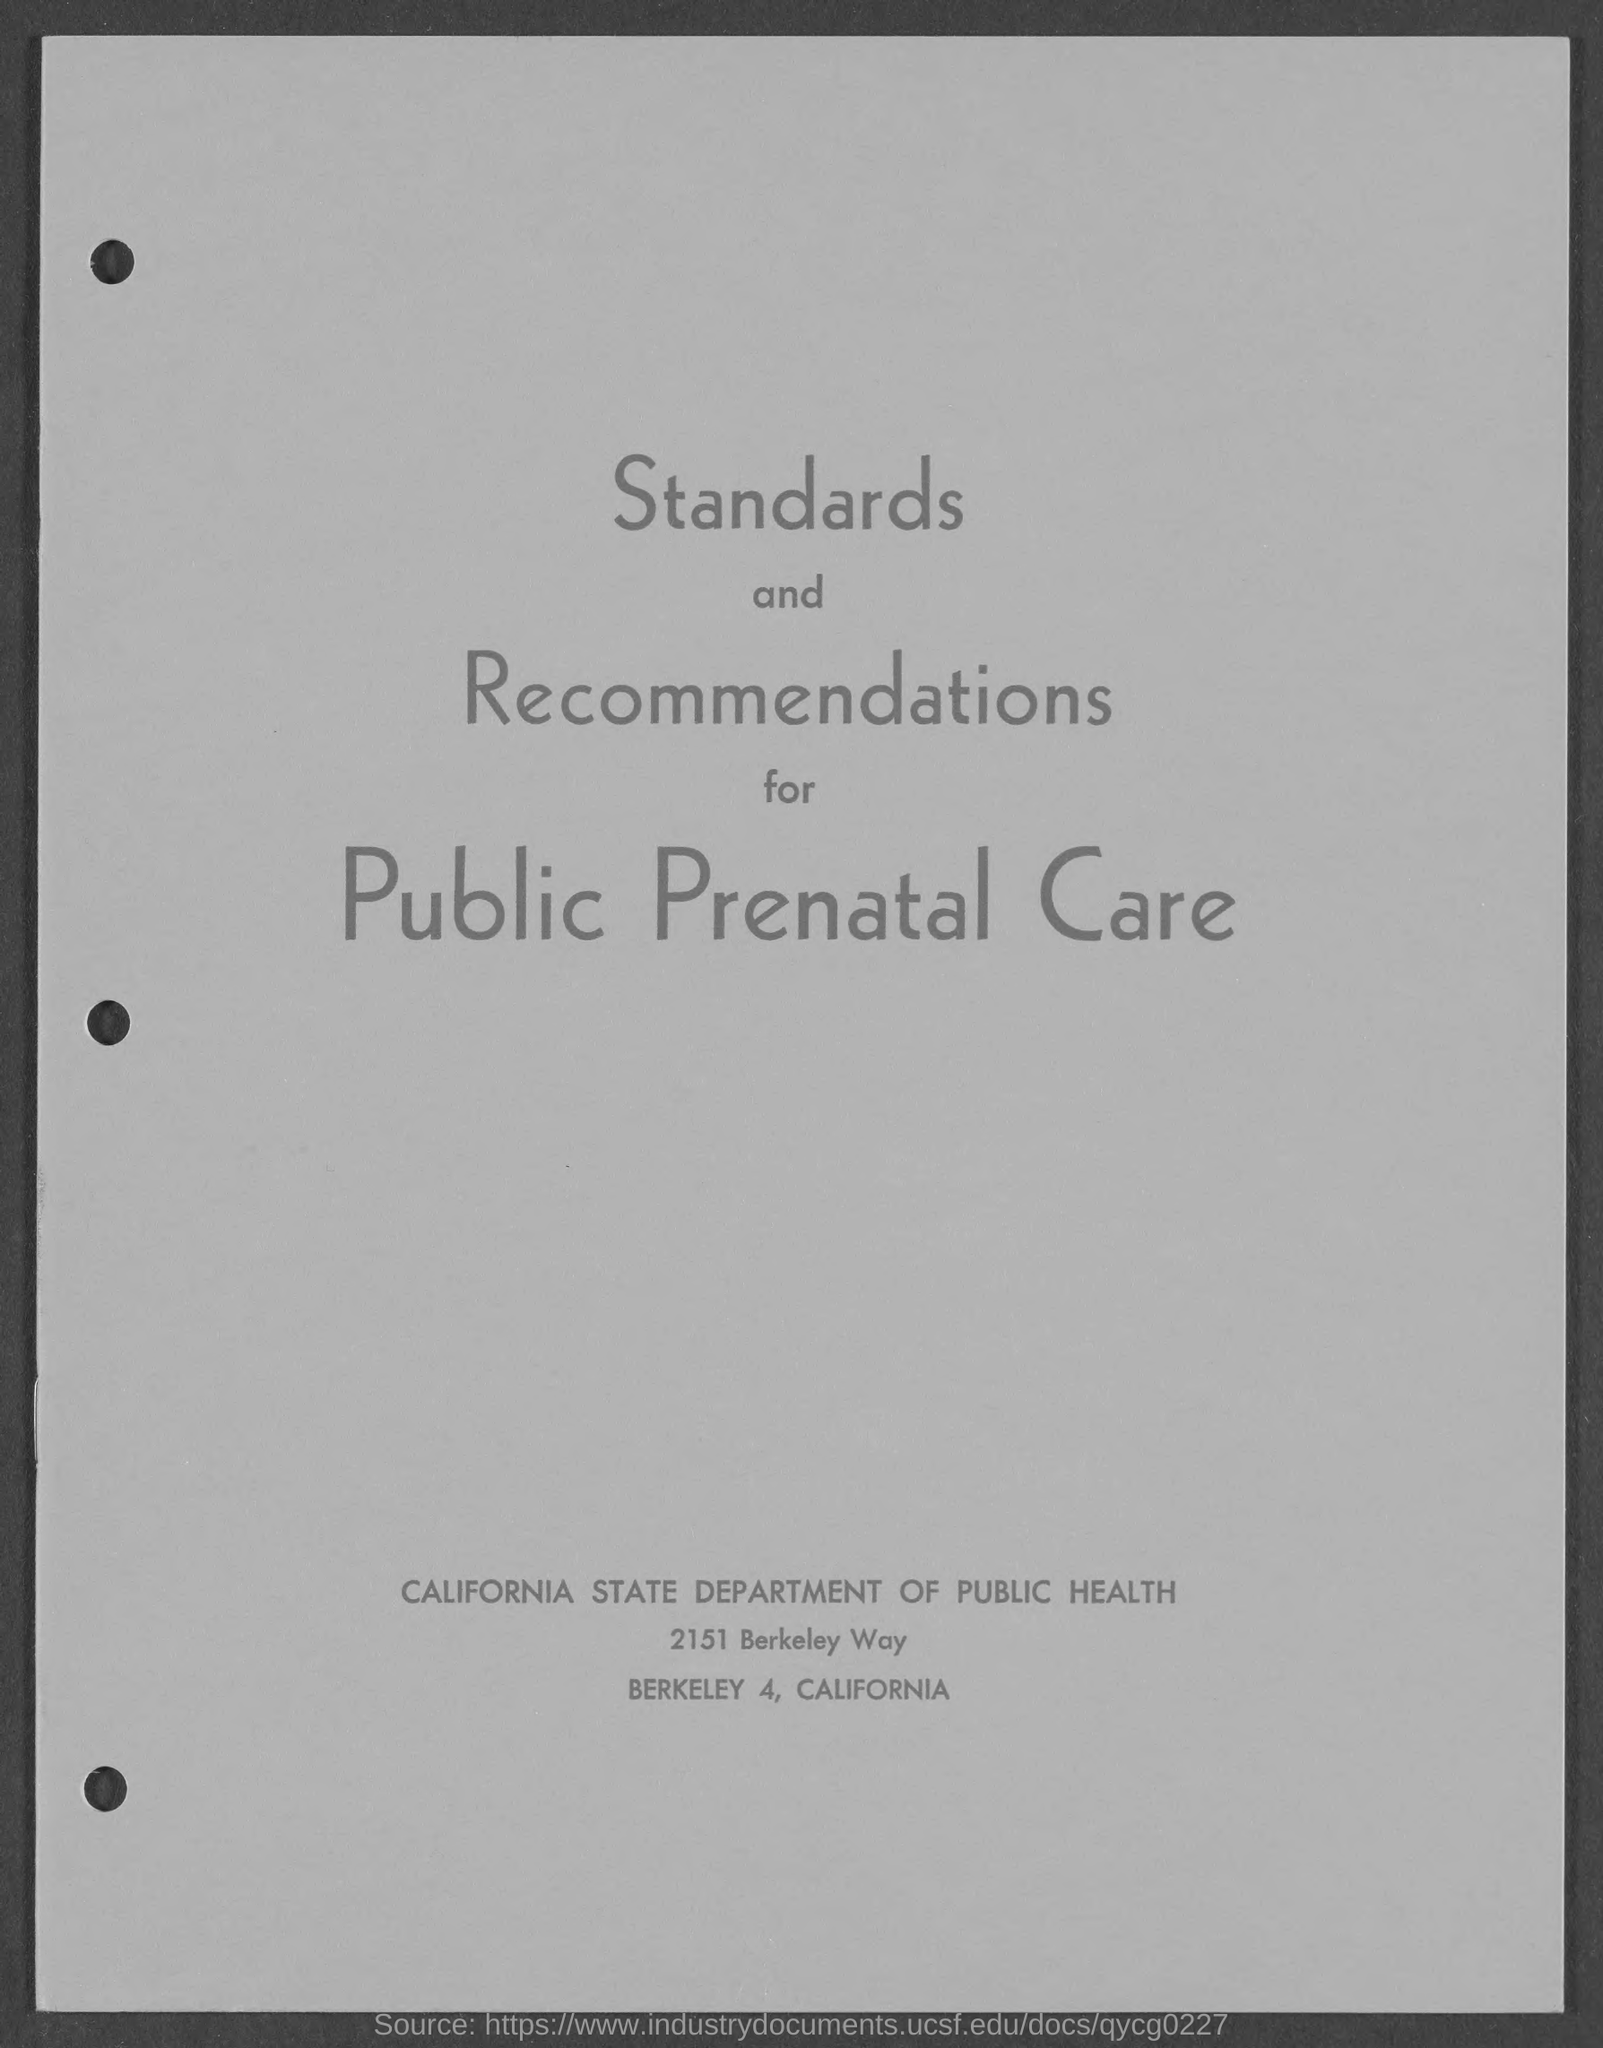Which standards and recommendations are given here?
Give a very brief answer. Standards and recommendations for public prenatal care. 